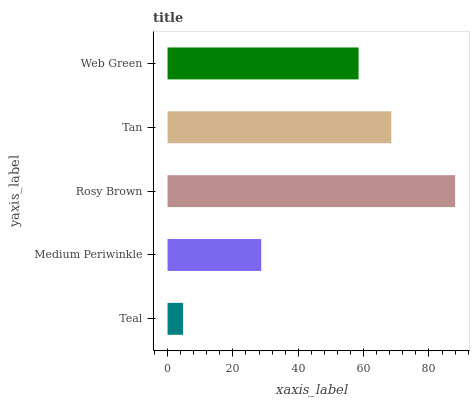Is Teal the minimum?
Answer yes or no. Yes. Is Rosy Brown the maximum?
Answer yes or no. Yes. Is Medium Periwinkle the minimum?
Answer yes or no. No. Is Medium Periwinkle the maximum?
Answer yes or no. No. Is Medium Periwinkle greater than Teal?
Answer yes or no. Yes. Is Teal less than Medium Periwinkle?
Answer yes or no. Yes. Is Teal greater than Medium Periwinkle?
Answer yes or no. No. Is Medium Periwinkle less than Teal?
Answer yes or no. No. Is Web Green the high median?
Answer yes or no. Yes. Is Web Green the low median?
Answer yes or no. Yes. Is Teal the high median?
Answer yes or no. No. Is Teal the low median?
Answer yes or no. No. 